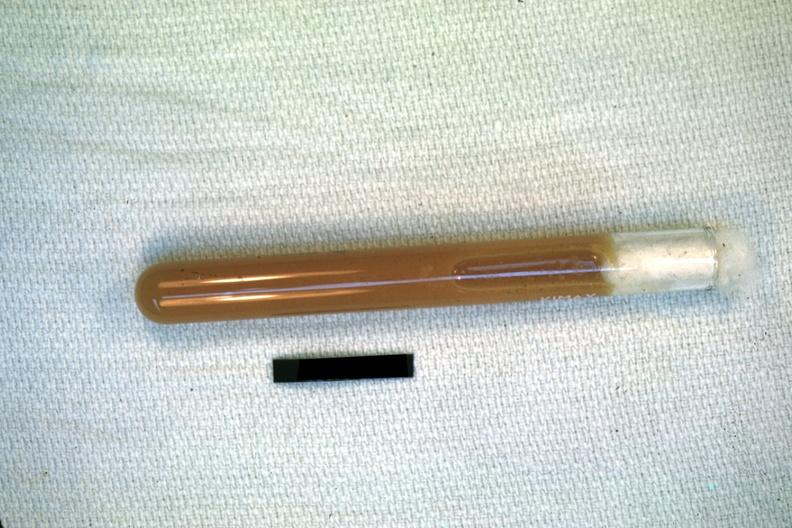what does this image show?
Answer the question using a single word or phrase. Case of peritonitis slide illustrates pus from the peritoneal cavity 